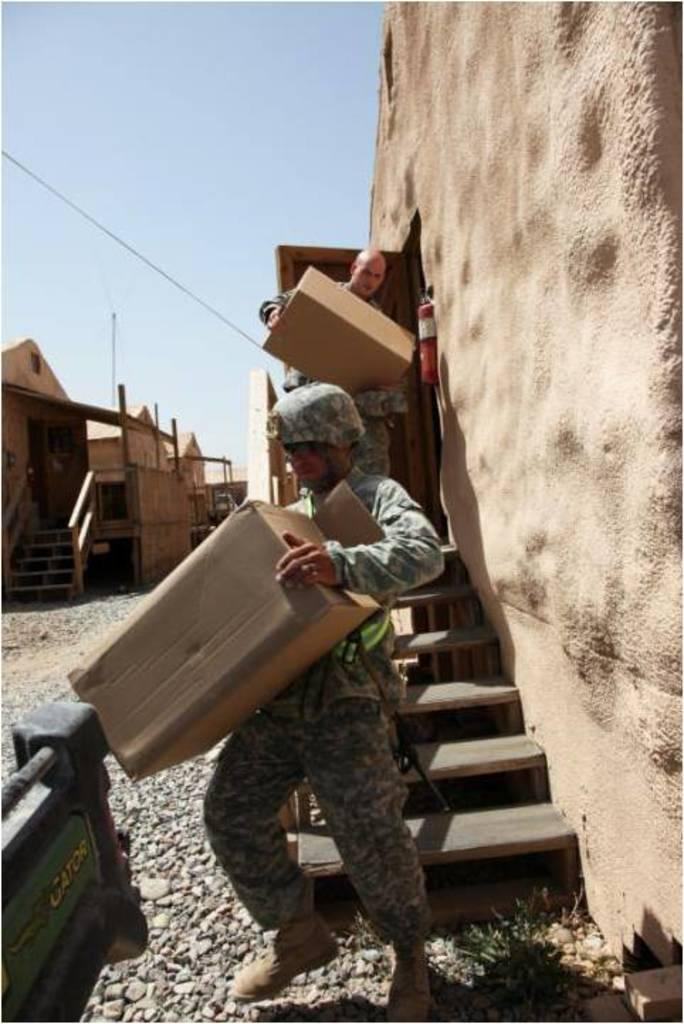How many people are in the image? There are 2 people in the image. What are the people holding in the image? The people are holding cartons. What architectural feature can be seen in the image? There are stairs in the image. What is on the right side of the image? There is a wall on the right side of the image. What can be seen on the left side of the image? There are buildings on the left side of the image. What is visible at the top of the image? The sky is visible at the top of the image. What type of nut is visible in the image? There is no nut present in the image. Whose teeth can be seen in the image? There are no teeth visible in the image. 